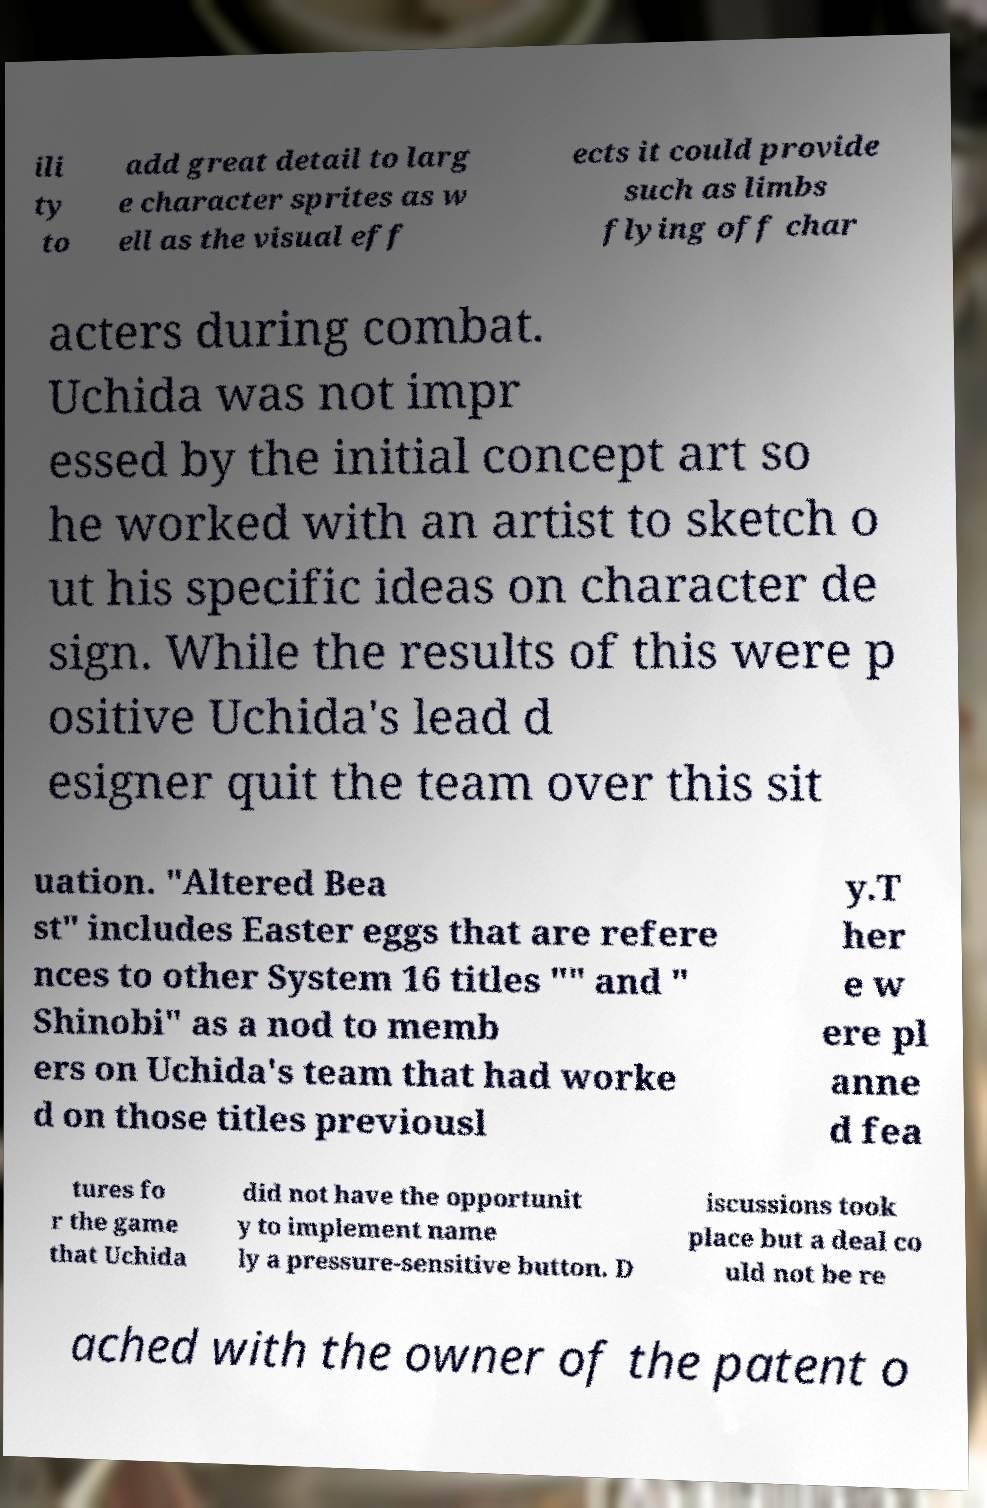Please identify and transcribe the text found in this image. ili ty to add great detail to larg e character sprites as w ell as the visual eff ects it could provide such as limbs flying off char acters during combat. Uchida was not impr essed by the initial concept art so he worked with an artist to sketch o ut his specific ideas on character de sign. While the results of this were p ositive Uchida's lead d esigner quit the team over this sit uation. "Altered Bea st" includes Easter eggs that are refere nces to other System 16 titles "" and " Shinobi" as a nod to memb ers on Uchida's team that had worke d on those titles previousl y.T her e w ere pl anne d fea tures fo r the game that Uchida did not have the opportunit y to implement name ly a pressure-sensitive button. D iscussions took place but a deal co uld not be re ached with the owner of the patent o 